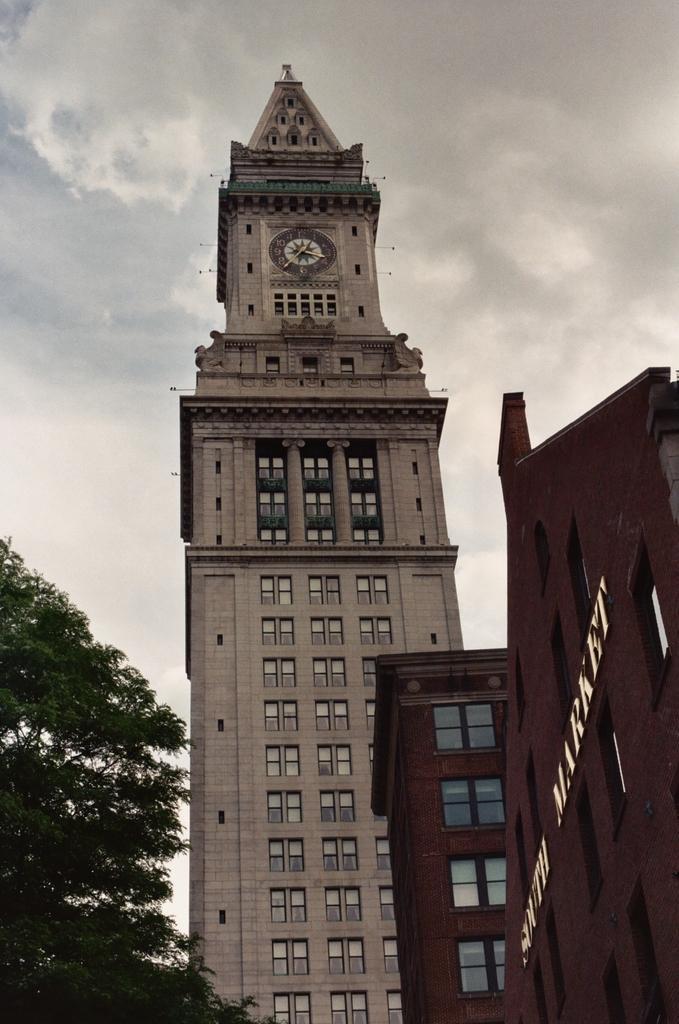How would you summarize this image in a sentence or two? In this picture we can see a clock tower. On the right side of the image, there are windows and a name board to the building. On the left side of the image, there is a tree. Behind the clock tower, where is the cloudy sky 